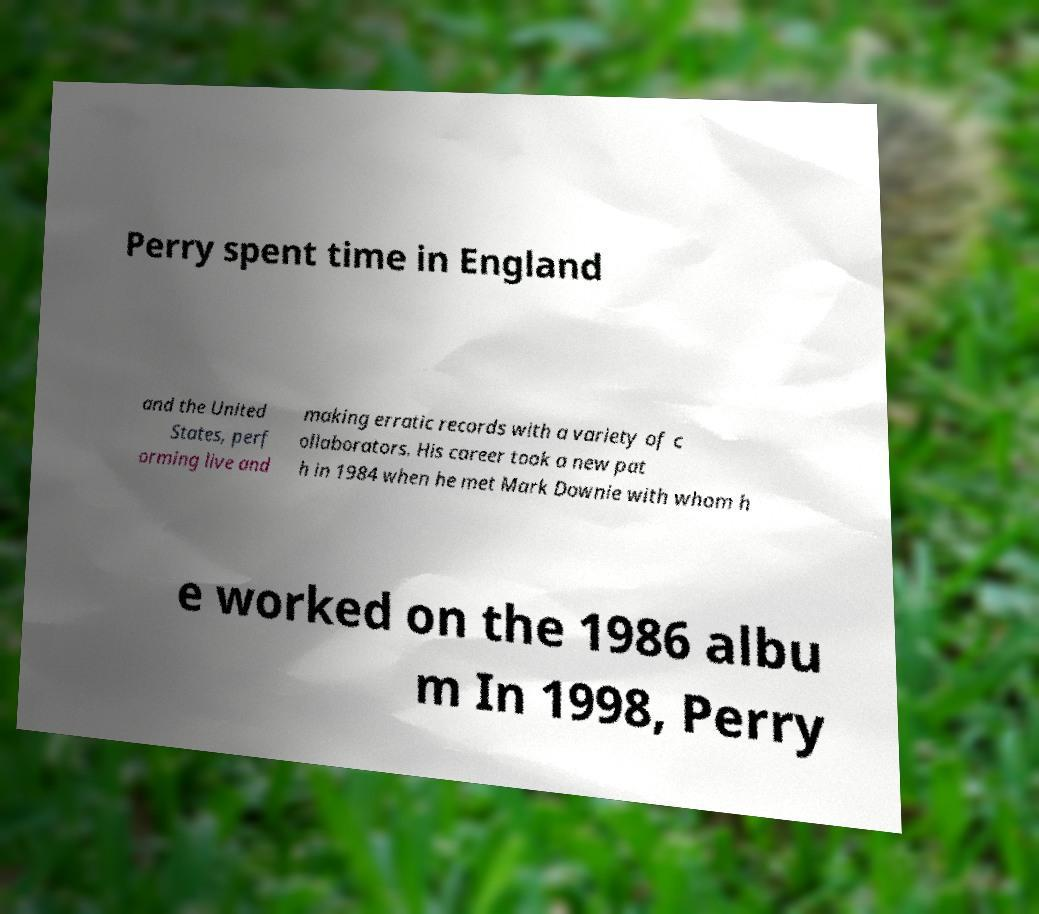What messages or text are displayed in this image? I need them in a readable, typed format. Perry spent time in England and the United States, perf orming live and making erratic records with a variety of c ollaborators. His career took a new pat h in 1984 when he met Mark Downie with whom h e worked on the 1986 albu m In 1998, Perry 